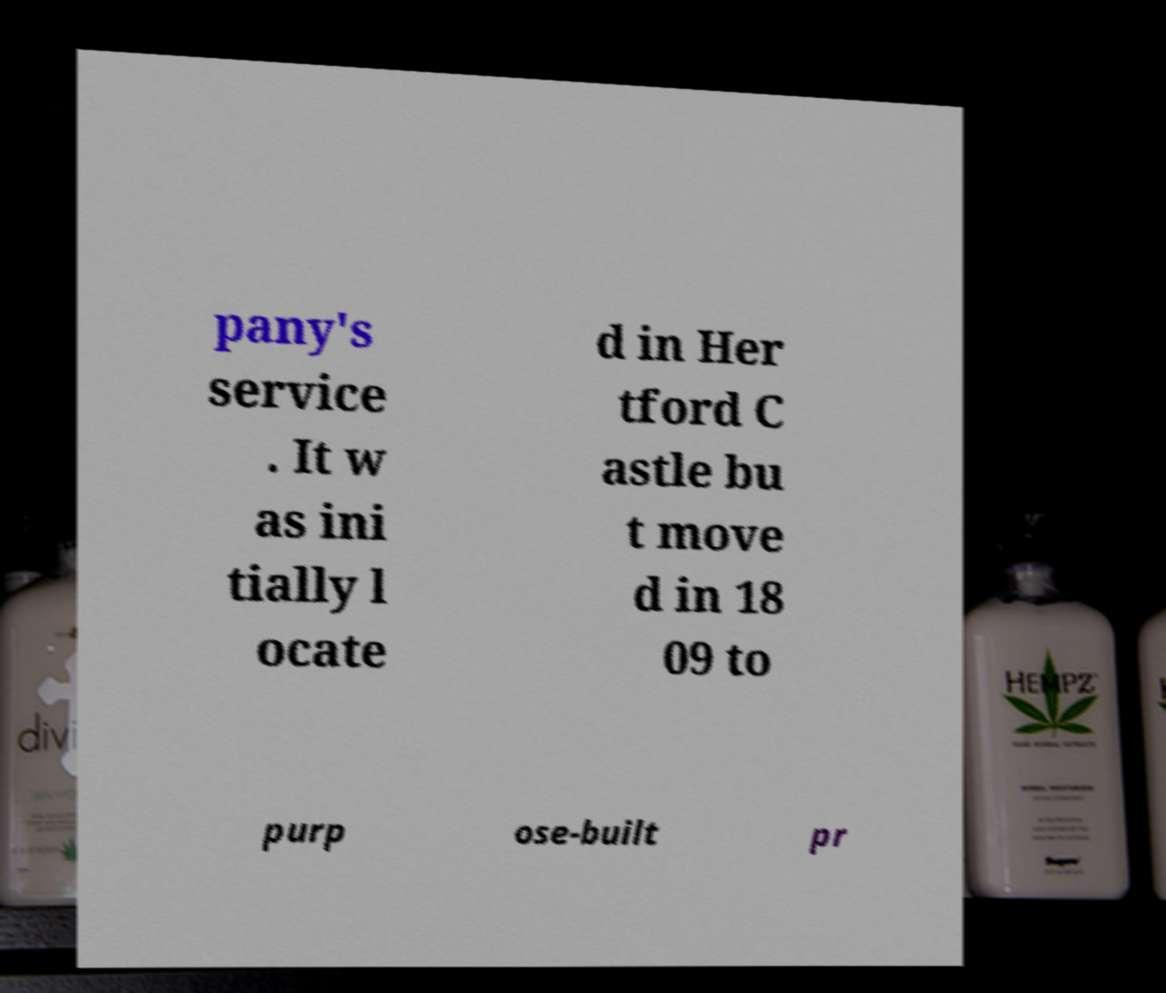There's text embedded in this image that I need extracted. Can you transcribe it verbatim? pany's service . It w as ini tially l ocate d in Her tford C astle bu t move d in 18 09 to purp ose-built pr 